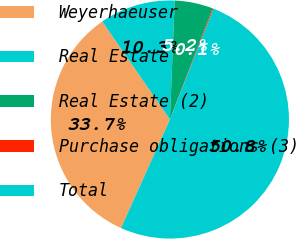Convert chart. <chart><loc_0><loc_0><loc_500><loc_500><pie_chart><fcel>Weyerhaeuser<fcel>Real Estate<fcel>Real Estate (2)<fcel>Purchase obligations (3)<fcel>Total<nl><fcel>33.66%<fcel>10.26%<fcel>5.19%<fcel>0.13%<fcel>50.76%<nl></chart> 